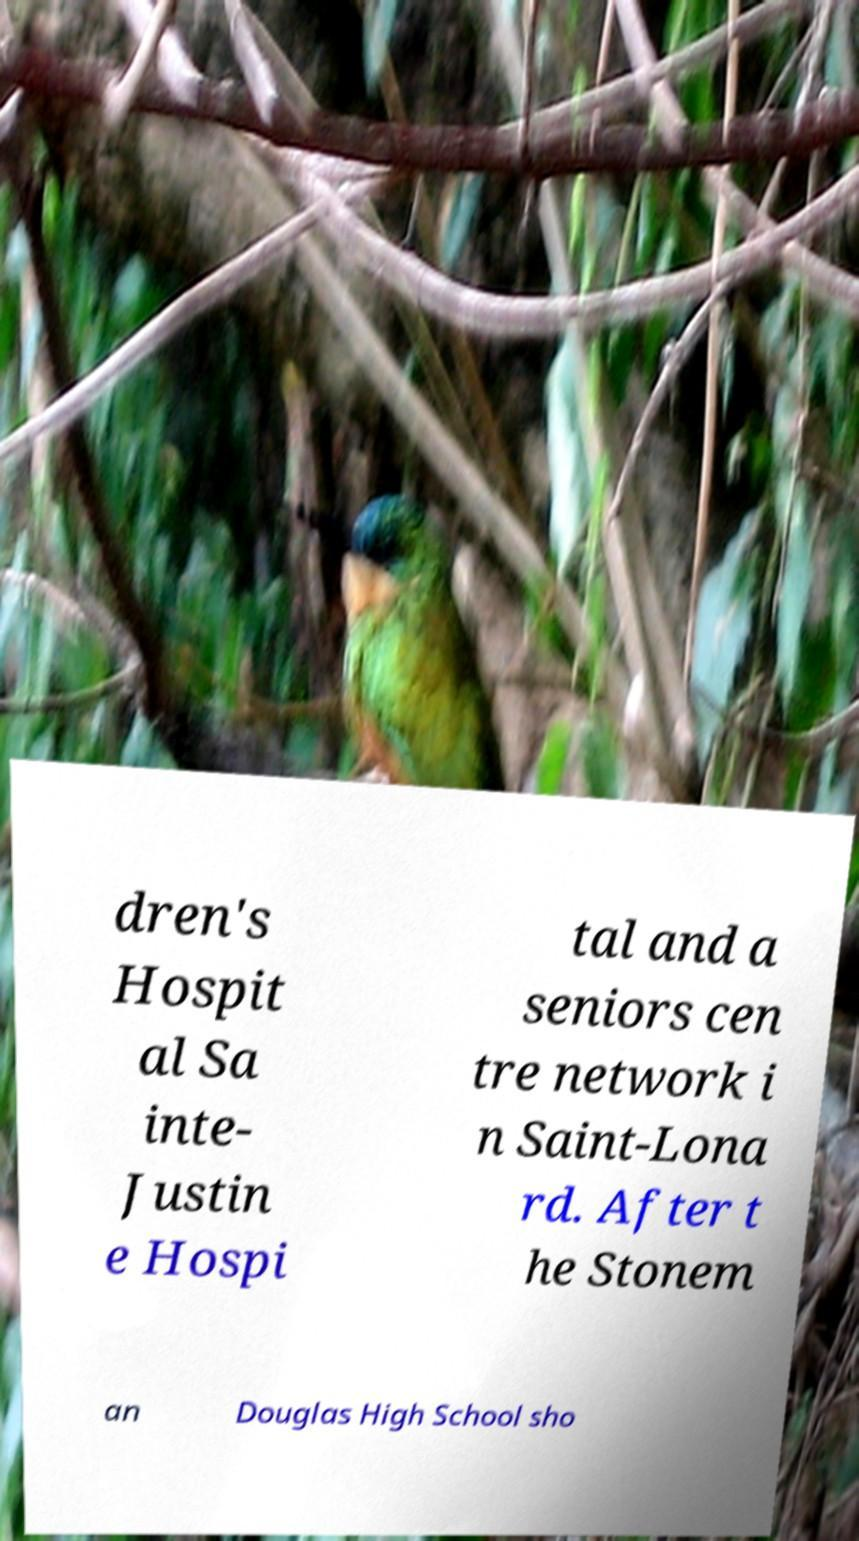I need the written content from this picture converted into text. Can you do that? dren's Hospit al Sa inte- Justin e Hospi tal and a seniors cen tre network i n Saint-Lona rd. After t he Stonem an Douglas High School sho 